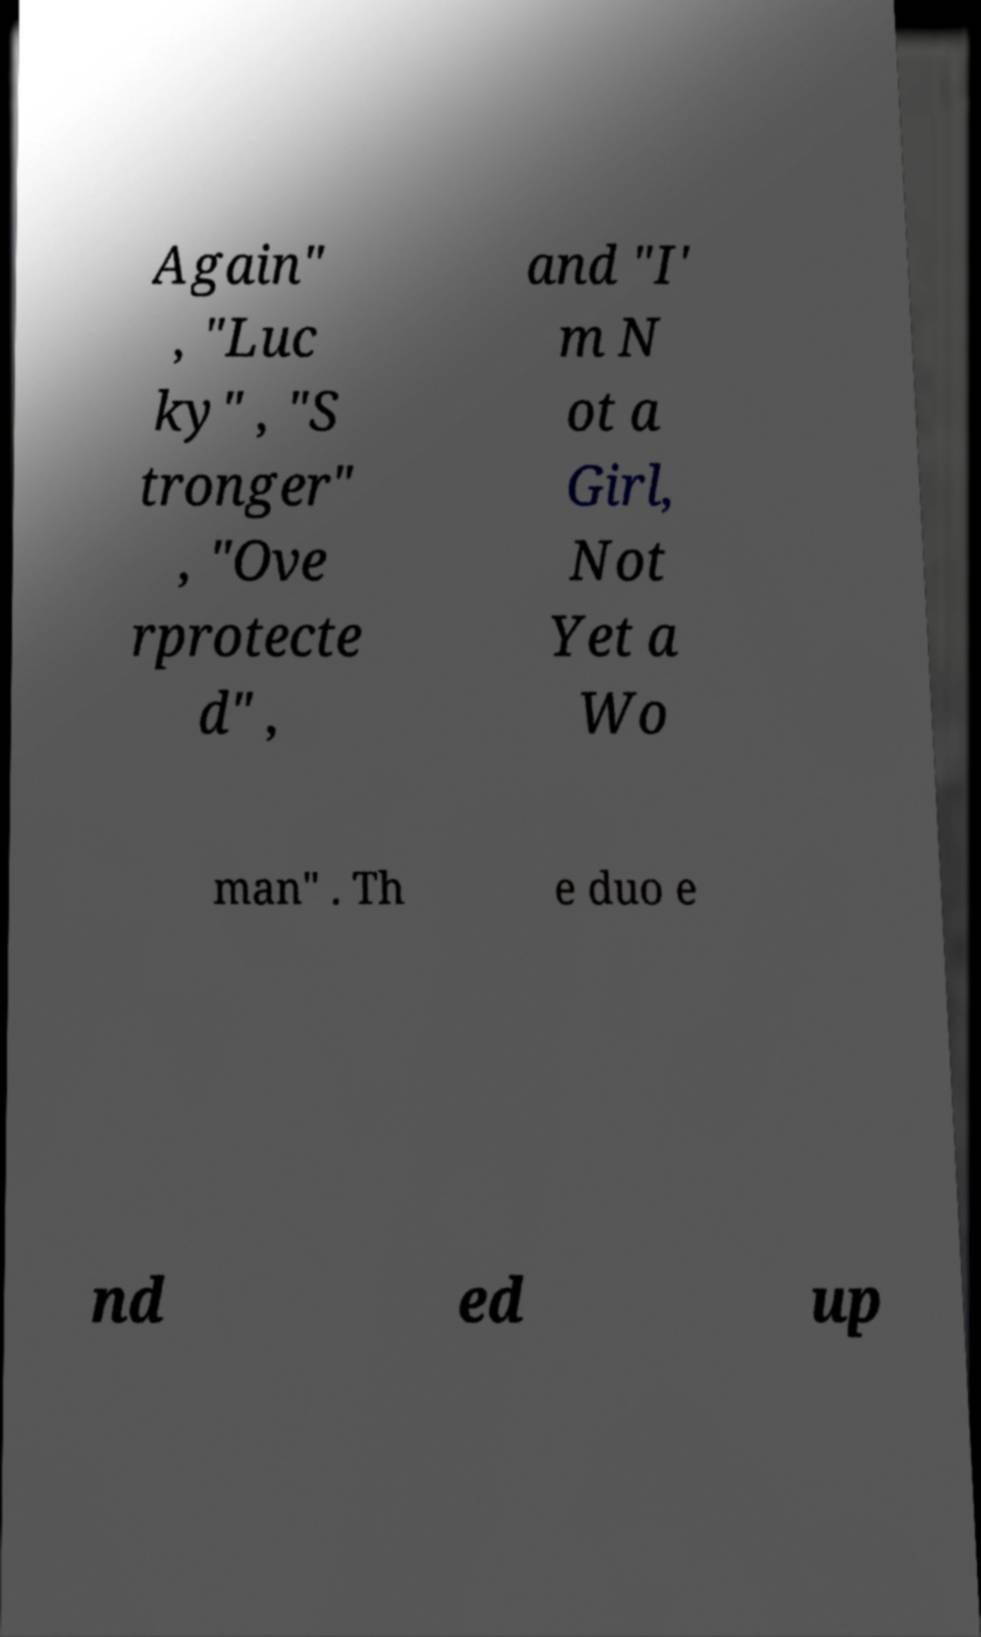I need the written content from this picture converted into text. Can you do that? Again" , "Luc ky" , "S tronger" , "Ove rprotecte d" , and "I' m N ot a Girl, Not Yet a Wo man" . Th e duo e nd ed up 